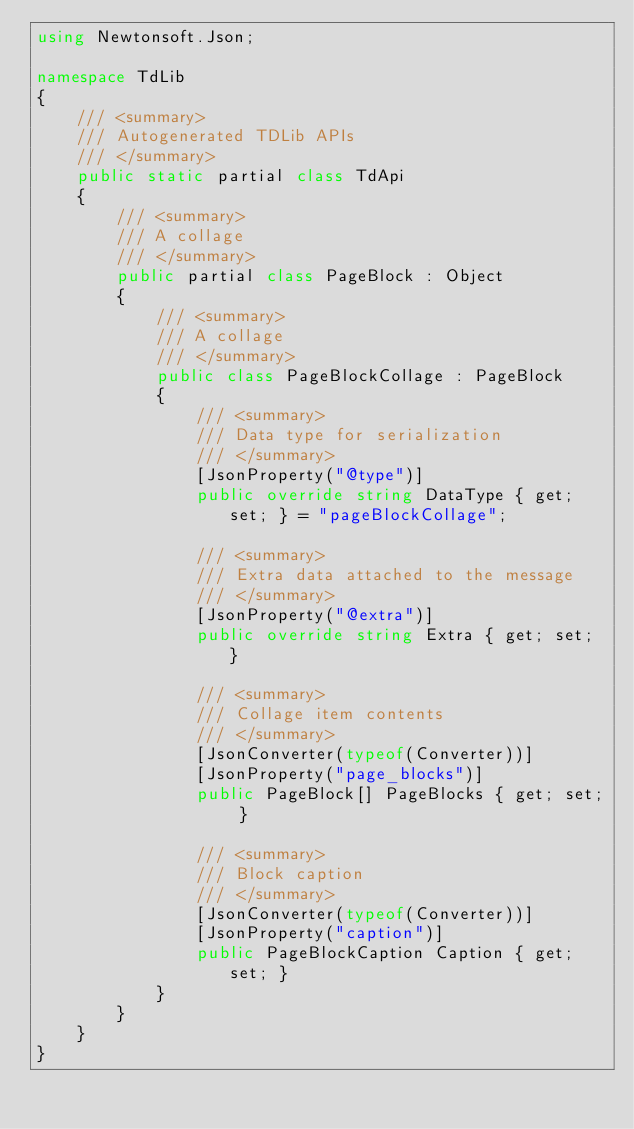Convert code to text. <code><loc_0><loc_0><loc_500><loc_500><_C#_>using Newtonsoft.Json;

namespace TdLib
{
    /// <summary>
    /// Autogenerated TDLib APIs
    /// </summary>
    public static partial class TdApi
    {
        /// <summary>
        /// A collage 
        /// </summary>
        public partial class PageBlock : Object
        {
            /// <summary>
            /// A collage 
            /// </summary>
            public class PageBlockCollage : PageBlock
            {
                /// <summary>
                /// Data type for serialization
                /// </summary>
                [JsonProperty("@type")]
                public override string DataType { get; set; } = "pageBlockCollage";

                /// <summary>
                /// Extra data attached to the message
                /// </summary>
                [JsonProperty("@extra")]
                public override string Extra { get; set; }

                /// <summary>
                /// Collage item contents 
                /// </summary>
                [JsonConverter(typeof(Converter))]
                [JsonProperty("page_blocks")]
                public PageBlock[] PageBlocks { get; set; }

                /// <summary>
                /// Block caption
                /// </summary>
                [JsonConverter(typeof(Converter))]
                [JsonProperty("caption")]
                public PageBlockCaption Caption { get; set; }
            }
        }
    }
}</code> 